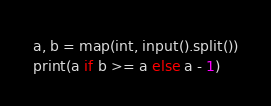<code> <loc_0><loc_0><loc_500><loc_500><_Python_>a, b = map(int, input().split())
print(a if b >= a else a - 1)
</code> 